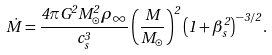Convert formula to latex. <formula><loc_0><loc_0><loc_500><loc_500>\dot { M } = \frac { 4 \pi G ^ { 2 } M _ { \odot } ^ { 2 } \rho _ { \infty } } { c _ { s } ^ { 3 } } \left ( \frac { M } { M _ { \odot } } \right ) ^ { 2 } \left ( 1 + \beta _ { s } ^ { 2 } \right ) ^ { - 3 / 2 } .</formula> 